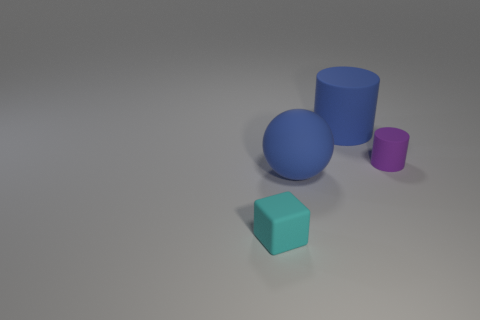Add 3 tiny purple metallic spheres. How many objects exist? 7 Subtract all balls. How many objects are left? 3 Add 4 cyan blocks. How many cyan blocks are left? 5 Add 1 tiny gray rubber things. How many tiny gray rubber things exist? 1 Subtract 0 gray cubes. How many objects are left? 4 Subtract all large rubber balls. Subtract all cubes. How many objects are left? 2 